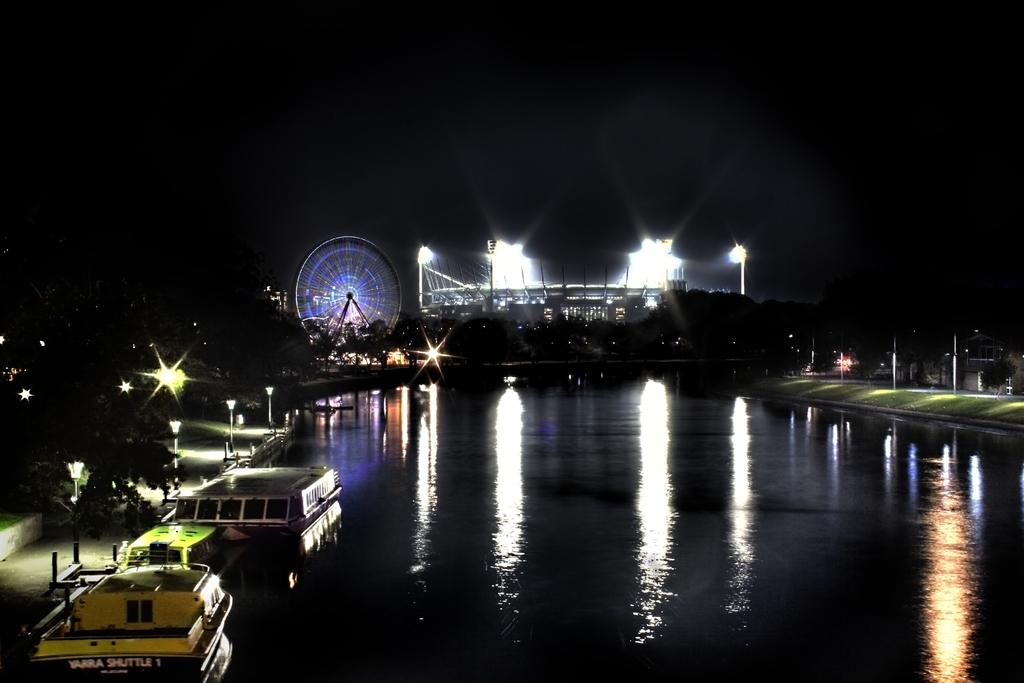What is the primary element visible in the image? There is water in the image. What can be seen in the foreground of the image? There are boats in the foreground of the image. What objects provide illumination in the image? There are lights in the image. What type of setting is depicted in the image? It appears to be a stage in the image. What is located in the background of the image? There is a giant wheel and lamp poles in the background. How much profit did the person make from the argument in the image? There is no person, profit, or argument present in the image. 